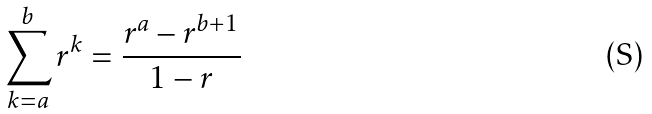<formula> <loc_0><loc_0><loc_500><loc_500>\sum _ { k = a } ^ { b } r ^ { k } = \frac { r ^ { a } - r ^ { b + 1 } } { 1 - r }</formula> 